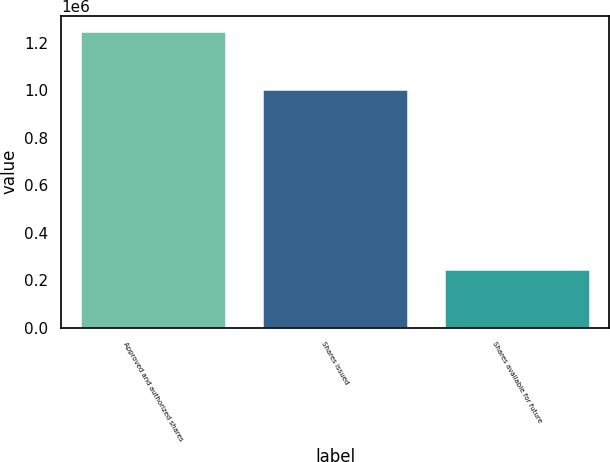Convert chart. <chart><loc_0><loc_0><loc_500><loc_500><bar_chart><fcel>Approved and authorized shares<fcel>Shares issued<fcel>Shares available for future<nl><fcel>1.25e+06<fcel>1.00243e+06<fcel>247567<nl></chart> 